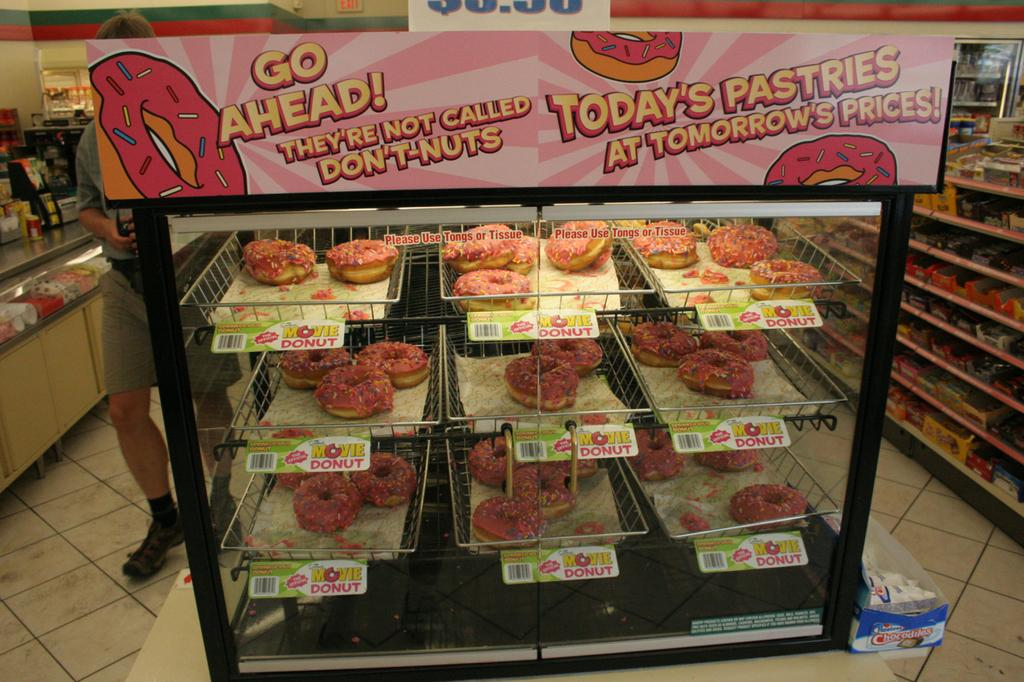<image>
Provide a brief description of the given image. You can get the special movie donut here 